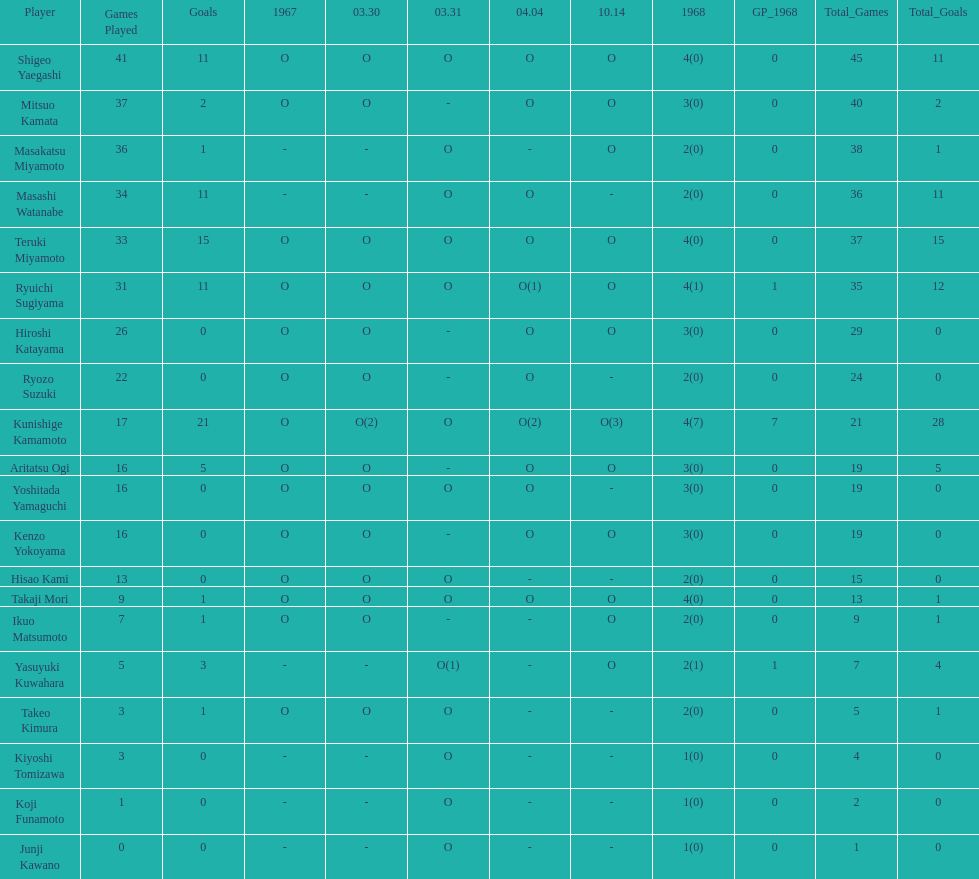How many more total appearances did shigeo yaegashi have than mitsuo kamata? 5. 